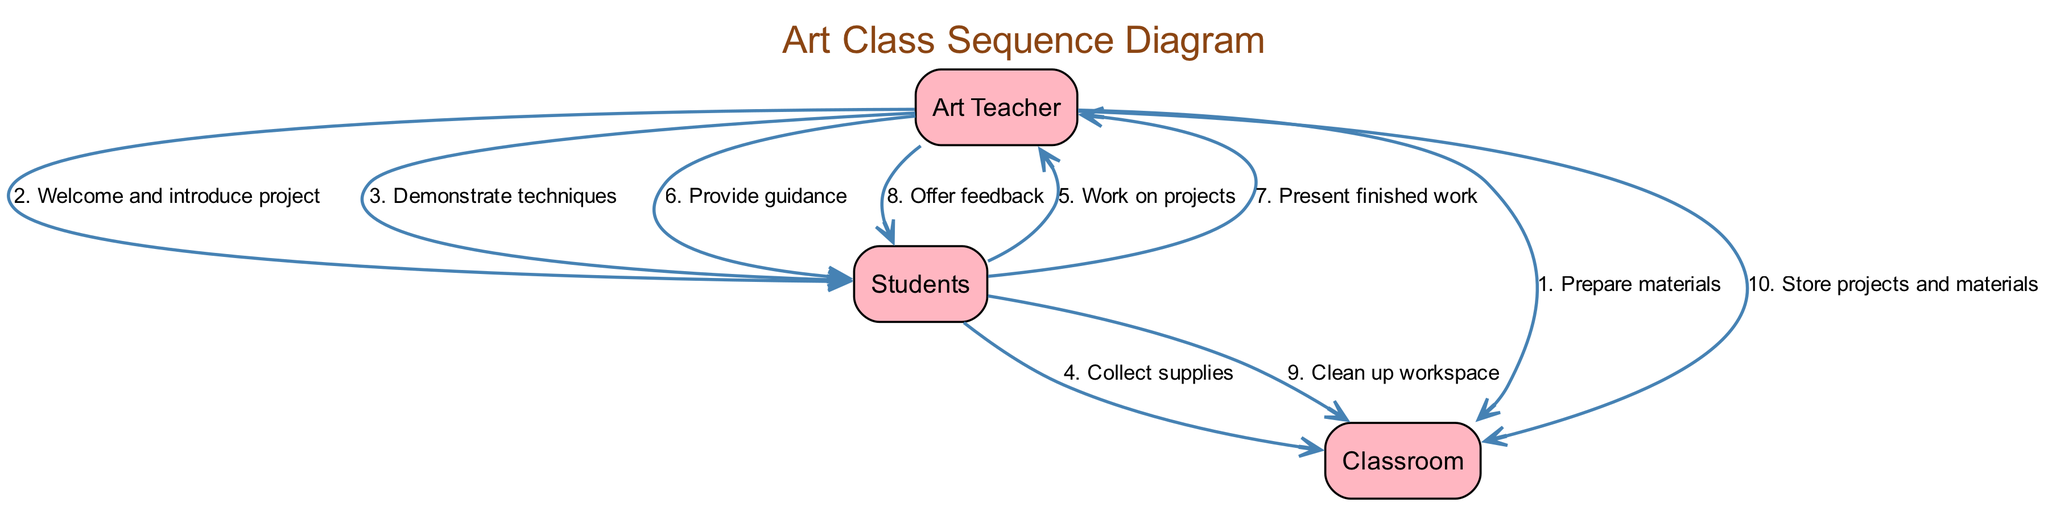What is the first action taken in the class? The first action listed in the events is "Prepare materials" performed by the Art Teacher directed to the Classroom.
Answer: Prepare materials How many actors are involved in the sequence? There are three actors involved: Art Teacher, Students, and Classroom.
Answer: 3 Which actor provides guidance? The Art Teacher is the one who provides guidance to the Students during the course of the class.
Answer: Art Teacher What is the last action performed in the sequence? The last action listed is "Store projects and materials" and is performed by the Art Teacher directed to the Classroom.
Answer: Store projects and materials What action do Students take before they present their finished work? Before presenting their finished work, Students "Work on projects" directed towards the Art Teacher.
Answer: Work on projects Which two actions involve feedback? The two actions involving feedback are "Present finished work" by Students directed to the Art Teacher and "Offer feedback" from the Art Teacher to Students.
Answer: Present finished work and Offer feedback How many total actions are in the sequence? There are ten actions listed in the sequence associated with the interactions between the actors.
Answer: 10 What is the relationship between the Students and Classroom during cleanup? During cleanup, the Students take an action "Clean up workspace" directed to the Classroom.
Answer: Clean up workspace Which event showcases the Art Teacher’s role in introducing the class? The event showcasing the Art Teacher's role is "Welcome and introduce project" directed towards the Students.
Answer: Welcome and introduce project 